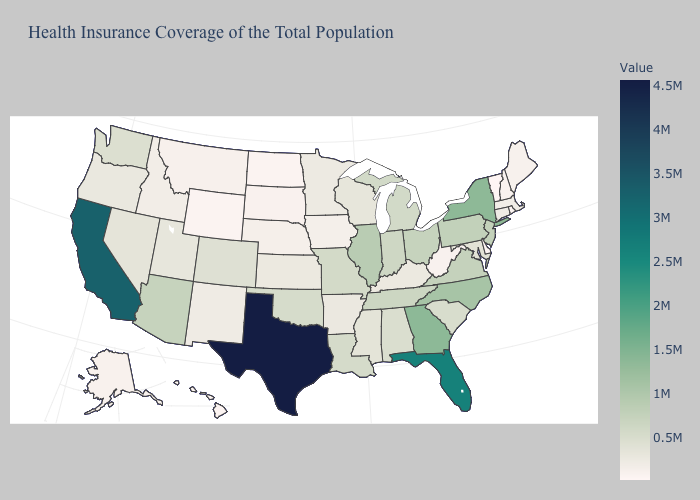Does Vermont have the lowest value in the USA?
Quick response, please. Yes. Does Vermont have a lower value than Pennsylvania?
Concise answer only. Yes. Among the states that border Nebraska , which have the lowest value?
Answer briefly. Wyoming. Is the legend a continuous bar?
Short answer required. Yes. Which states have the lowest value in the South?
Write a very short answer. Delaware. 